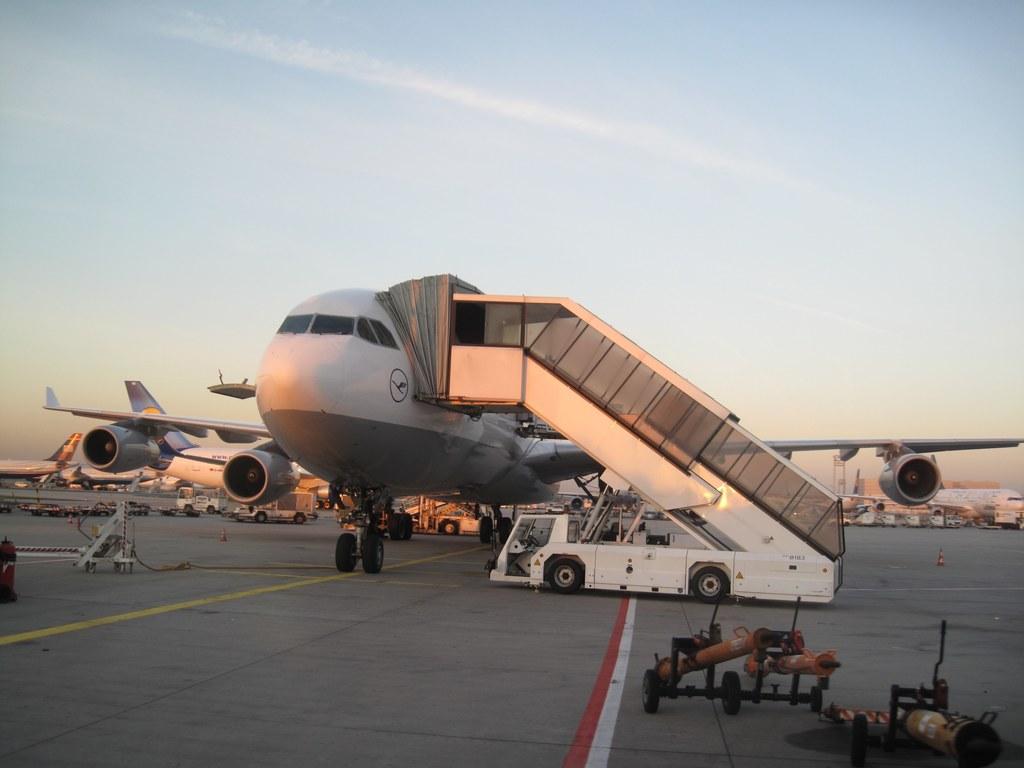Could you give a brief overview of what you see in this image? In this image there is an airplane in the middle. In the background there are so many airplanes on the runway. On the right side bottom there are cylinders. In the middle it looks like a vehicle which is used by the passengers to enter into the airplane. At the top there is the sky. 